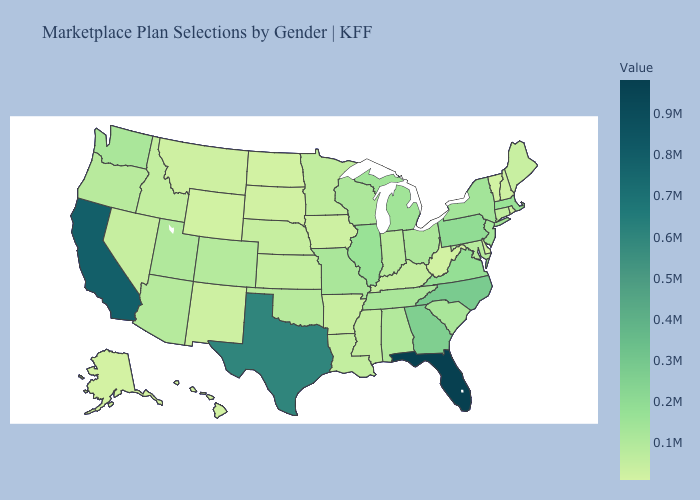Does Montana have the lowest value in the West?
Give a very brief answer. No. Among the states that border Delaware , which have the highest value?
Concise answer only. Pennsylvania. Does Alaska have the lowest value in the USA?
Keep it brief. Yes. Which states have the lowest value in the USA?
Quick response, please. Alaska. Is the legend a continuous bar?
Write a very short answer. Yes. Does Florida have the highest value in the USA?
Write a very short answer. Yes. 